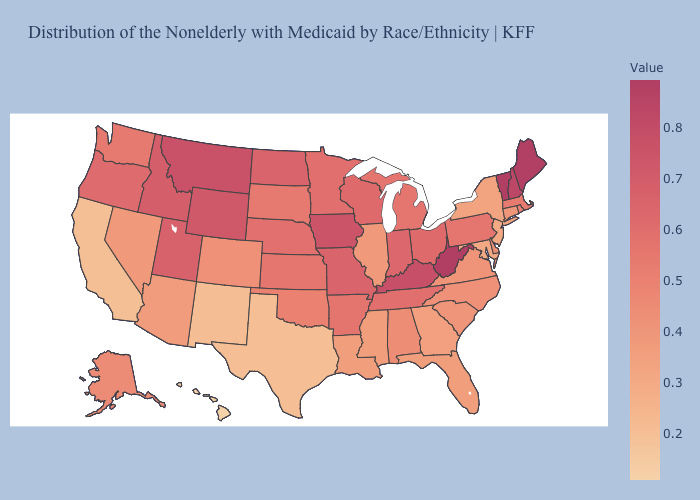Does Iowa have the highest value in the MidWest?
Be succinct. Yes. Does Iowa have the highest value in the MidWest?
Answer briefly. Yes. Which states have the highest value in the USA?
Keep it brief. Vermont. Among the states that border Virginia , which have the lowest value?
Short answer required. Maryland. 